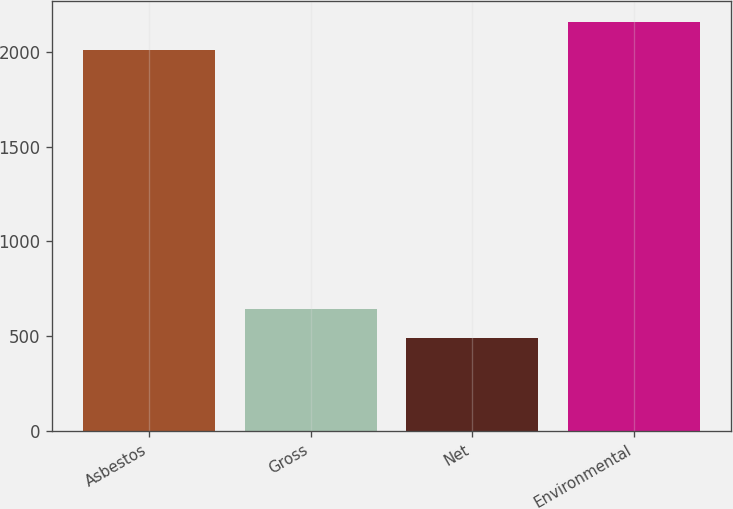<chart> <loc_0><loc_0><loc_500><loc_500><bar_chart><fcel>Asbestos<fcel>Gross<fcel>Net<fcel>Environmental<nl><fcel>2009<fcel>641.9<fcel>490<fcel>2160.9<nl></chart> 